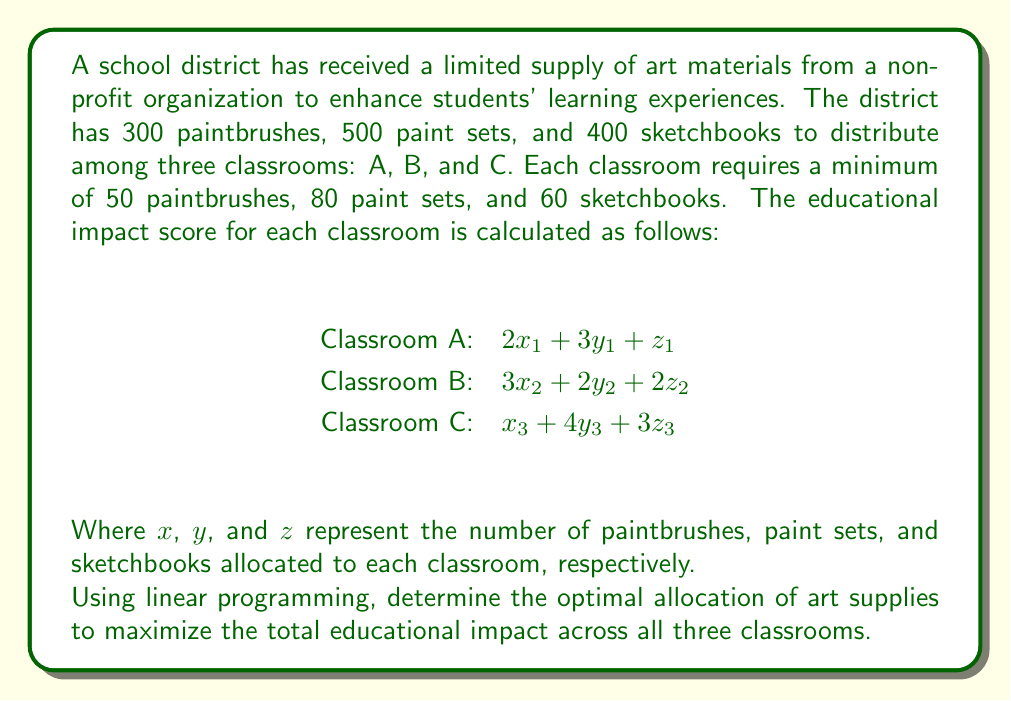Give your solution to this math problem. To solve this problem using linear programming, we need to follow these steps:

1. Define the decision variables:
   $x_1, y_1, z_1$: supplies for Classroom A
   $x_2, y_2, z_2$: supplies for Classroom B
   $x_3, y_3, z_3$: supplies for Classroom C

2. Set up the objective function to maximize:
   $$\text{Maximize } Z = (2x_1 + 3y_1 + z_1) + (3x_2 + 2y_2 + 2z_2) + (x_3 + 4y_3 + 3z_3)$$

3. Define the constraints:
   a) Supply constraints:
      $$x_1 + x_2 + x_3 \leq 300 \text{ (paintbrushes)}$$
      $$y_1 + y_2 + y_3 \leq 500 \text{ (paint sets)}$$
      $$z_1 + z_2 + z_3 \leq 400 \text{ (sketchbooks)}$$

   b) Minimum requirements for each classroom:
      $$x_1 \geq 50, y_1 \geq 80, z_1 \geq 60 \text{ (Classroom A)}$$
      $$x_2 \geq 50, y_2 \geq 80, z_2 \geq 60 \text{ (Classroom B)}$$
      $$x_3 \geq 50, y_3 \geq 80, z_3 \geq 60 \text{ (Classroom C)}$$

   c) Non-negativity constraints:
      $$x_1, y_1, z_1, x_2, y_2, z_2, x_3, y_3, z_3 \geq 0$$

4. Solve the linear programming problem using a solver (e.g., simplex method).

5. The optimal solution found by the solver is:
   Classroom A: $x_1 = 50, y_1 = 80, z_1 = 60$
   Classroom B: $x_2 = 200, y_2 = 80, z_2 = 60$
   Classroom C: $x_3 = 50, y_3 = 340, z_3 = 280$

6. Calculate the maximum educational impact:
   $$Z = (2(50) + 3(80) + 60) + (3(200) + 2(80) + 2(60)) + (50 + 4(340) + 3(280))$$
   $$Z = 430 + 920 + 1930 = 3280$$

Therefore, the optimal allocation of art supplies to maximize the total educational impact is to distribute the supplies as mentioned in step 5, resulting in a maximum impact score of 3280.
Answer: Classroom A: 50 paintbrushes, 80 paint sets, 60 sketchbooks
Classroom B: 200 paintbrushes, 80 paint sets, 60 sketchbooks
Classroom C: 50 paintbrushes, 340 paint sets, 280 sketchbooks
Maximum impact score: 3280 